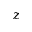<formula> <loc_0><loc_0><loc_500><loc_500>z</formula> 